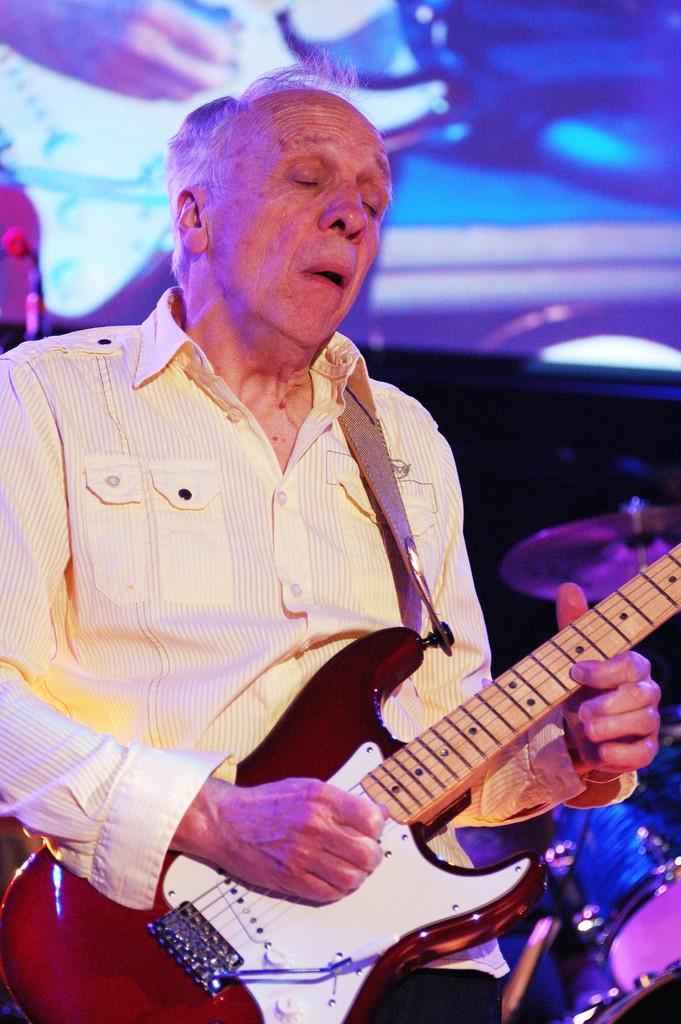Could you give a brief overview of what you see in this image? a person is holding guitar. behind him at the right there are drums. 